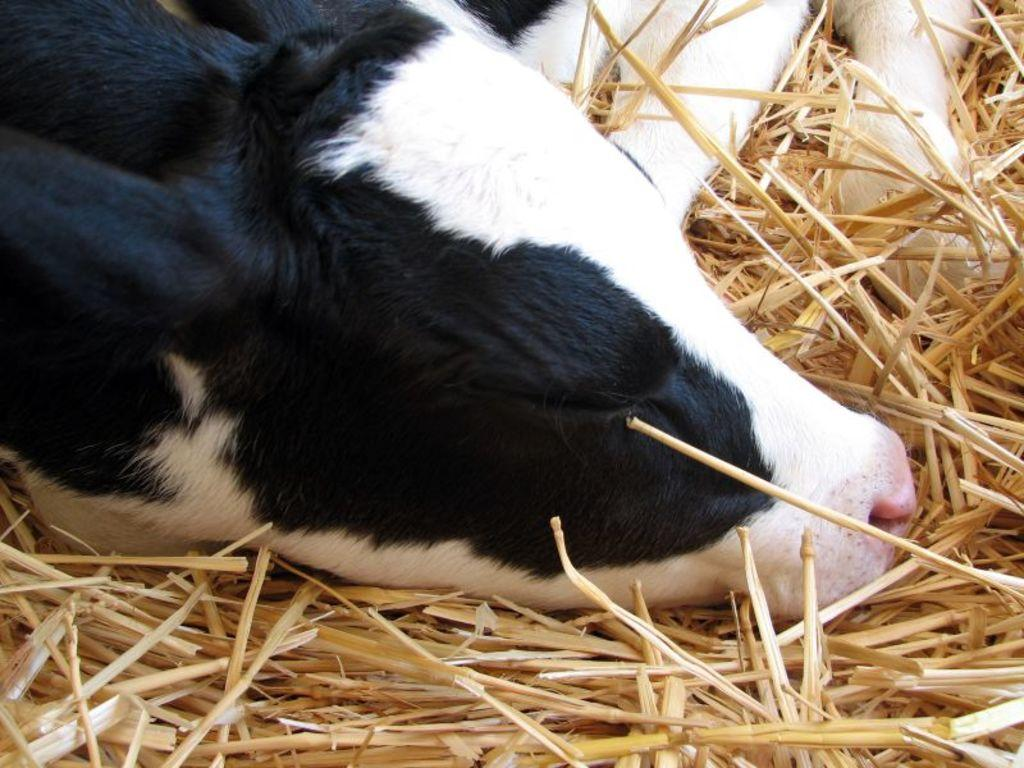What is present in the image? There is an animal in the image. What is the animal doing? The animal is sleeping. Where is the animal located? The animal is on the lawn straw. How many lights are visible on the table in the image? There is no table or lights present in the image; it features an animal sleeping on the lawn straw. 